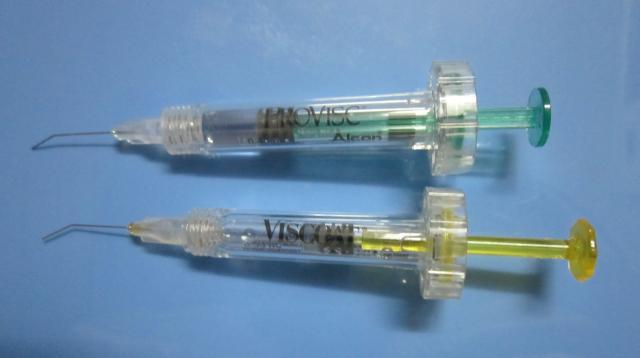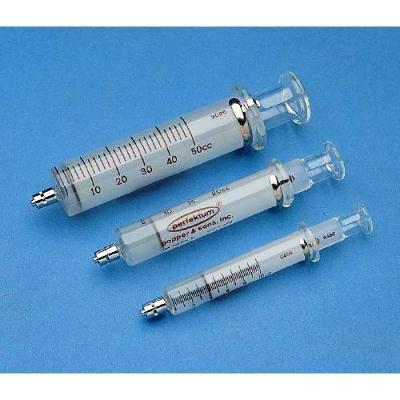The first image is the image on the left, the second image is the image on the right. For the images displayed, is the sentence "The right image contains two clear syringes." factually correct? Answer yes or no. No. 